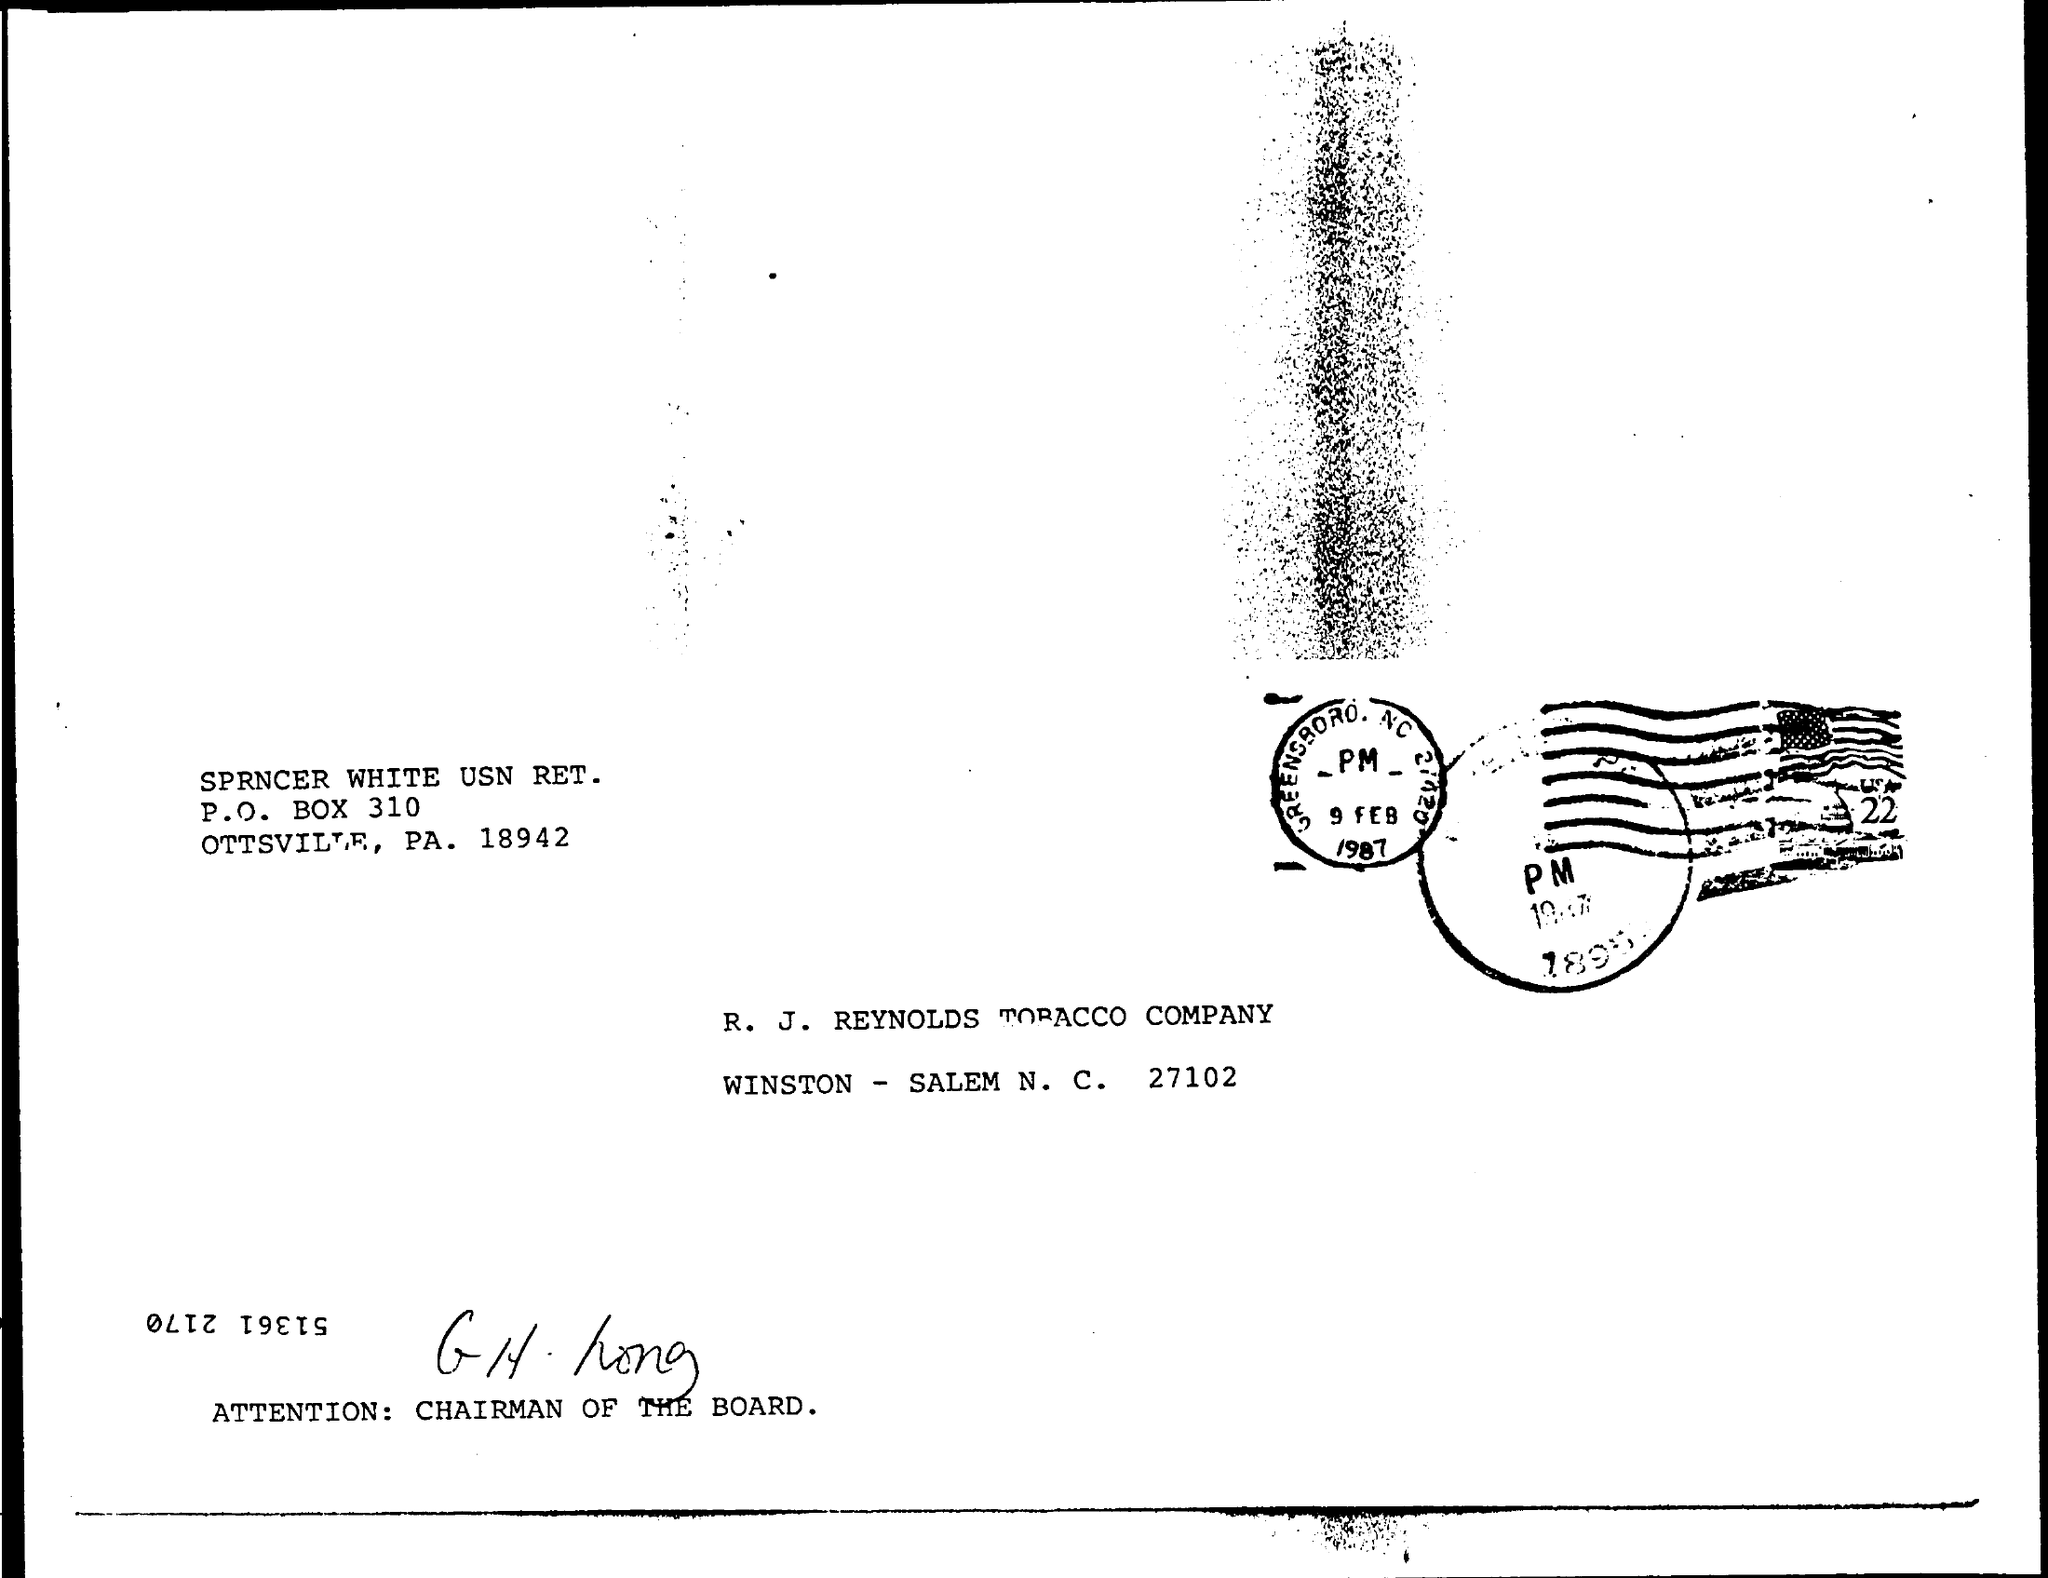Indicate a few pertinent items in this graphic. The date written on the stamp is February 9, 1987. 